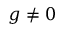<formula> <loc_0><loc_0><loc_500><loc_500>g \neq 0</formula> 